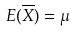Convert formula to latex. <formula><loc_0><loc_0><loc_500><loc_500>E ( \overline { X } ) = \mu</formula> 